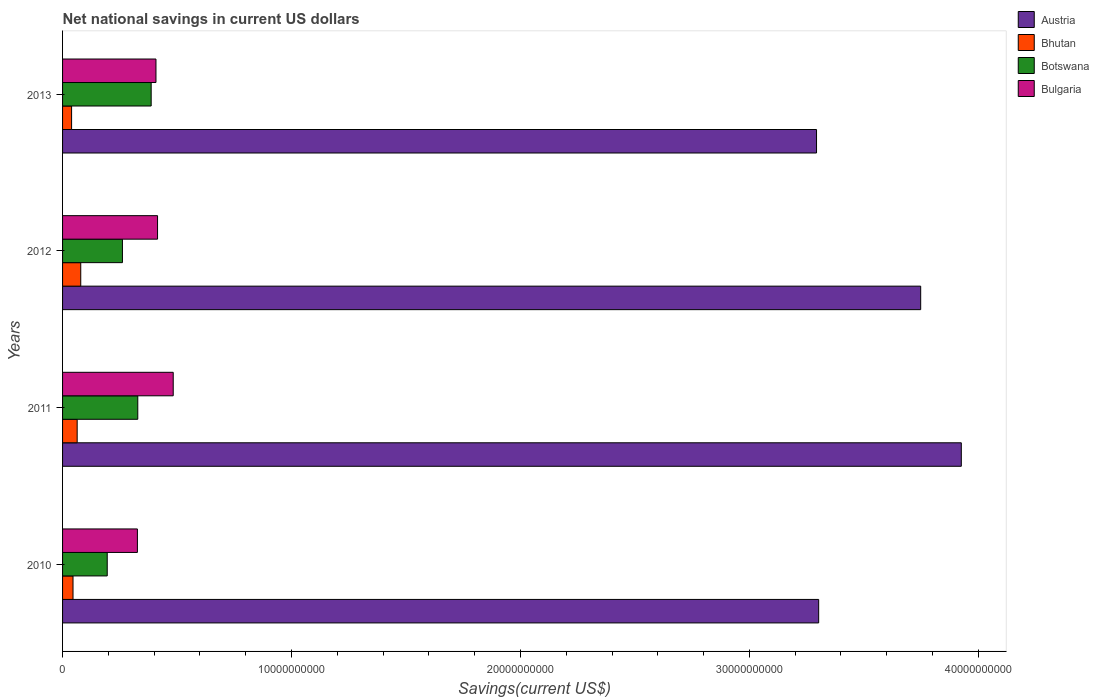How many groups of bars are there?
Make the answer very short. 4. Are the number of bars per tick equal to the number of legend labels?
Ensure brevity in your answer.  Yes. How many bars are there on the 2nd tick from the bottom?
Provide a short and direct response. 4. What is the net national savings in Botswana in 2010?
Give a very brief answer. 1.95e+09. Across all years, what is the maximum net national savings in Austria?
Ensure brevity in your answer.  3.93e+1. Across all years, what is the minimum net national savings in Botswana?
Your response must be concise. 1.95e+09. What is the total net national savings in Bhutan in the graph?
Offer a terse response. 2.28e+09. What is the difference between the net national savings in Austria in 2010 and that in 2013?
Give a very brief answer. 9.34e+07. What is the difference between the net national savings in Botswana in 2011 and the net national savings in Austria in 2012?
Make the answer very short. -3.42e+1. What is the average net national savings in Bhutan per year?
Provide a short and direct response. 5.71e+08. In the year 2011, what is the difference between the net national savings in Austria and net national savings in Bulgaria?
Keep it short and to the point. 3.44e+1. What is the ratio of the net national savings in Bulgaria in 2012 to that in 2013?
Provide a short and direct response. 1.02. Is the difference between the net national savings in Austria in 2011 and 2013 greater than the difference between the net national savings in Bulgaria in 2011 and 2013?
Keep it short and to the point. Yes. What is the difference between the highest and the second highest net national savings in Austria?
Offer a very short reply. 1.77e+09. What is the difference between the highest and the lowest net national savings in Botswana?
Provide a succinct answer. 1.92e+09. Is the sum of the net national savings in Bulgaria in 2011 and 2012 greater than the maximum net national savings in Botswana across all years?
Provide a succinct answer. Yes. What does the 4th bar from the top in 2010 represents?
Provide a succinct answer. Austria. Is it the case that in every year, the sum of the net national savings in Bhutan and net national savings in Botswana is greater than the net national savings in Bulgaria?
Offer a terse response. No. How many bars are there?
Ensure brevity in your answer.  16. Where does the legend appear in the graph?
Give a very brief answer. Top right. How many legend labels are there?
Your answer should be compact. 4. What is the title of the graph?
Offer a terse response. Net national savings in current US dollars. Does "Macedonia" appear as one of the legend labels in the graph?
Offer a terse response. No. What is the label or title of the X-axis?
Provide a succinct answer. Savings(current US$). What is the Savings(current US$) in Austria in 2010?
Make the answer very short. 3.30e+1. What is the Savings(current US$) of Bhutan in 2010?
Give a very brief answer. 4.57e+08. What is the Savings(current US$) in Botswana in 2010?
Ensure brevity in your answer.  1.95e+09. What is the Savings(current US$) of Bulgaria in 2010?
Offer a terse response. 3.27e+09. What is the Savings(current US$) of Austria in 2011?
Your response must be concise. 3.93e+1. What is the Savings(current US$) in Bhutan in 2011?
Give a very brief answer. 6.38e+08. What is the Savings(current US$) of Botswana in 2011?
Offer a very short reply. 3.29e+09. What is the Savings(current US$) in Bulgaria in 2011?
Make the answer very short. 4.83e+09. What is the Savings(current US$) in Austria in 2012?
Keep it short and to the point. 3.75e+1. What is the Savings(current US$) of Bhutan in 2012?
Your response must be concise. 7.94e+08. What is the Savings(current US$) in Botswana in 2012?
Your answer should be very brief. 2.62e+09. What is the Savings(current US$) of Bulgaria in 2012?
Offer a terse response. 4.15e+09. What is the Savings(current US$) in Austria in 2013?
Keep it short and to the point. 3.29e+1. What is the Savings(current US$) of Bhutan in 2013?
Give a very brief answer. 3.94e+08. What is the Savings(current US$) of Botswana in 2013?
Keep it short and to the point. 3.87e+09. What is the Savings(current US$) of Bulgaria in 2013?
Provide a short and direct response. 4.08e+09. Across all years, what is the maximum Savings(current US$) of Austria?
Your answer should be very brief. 3.93e+1. Across all years, what is the maximum Savings(current US$) of Bhutan?
Offer a very short reply. 7.94e+08. Across all years, what is the maximum Savings(current US$) of Botswana?
Keep it short and to the point. 3.87e+09. Across all years, what is the maximum Savings(current US$) of Bulgaria?
Offer a very short reply. 4.83e+09. Across all years, what is the minimum Savings(current US$) of Austria?
Provide a succinct answer. 3.29e+1. Across all years, what is the minimum Savings(current US$) in Bhutan?
Your response must be concise. 3.94e+08. Across all years, what is the minimum Savings(current US$) in Botswana?
Provide a succinct answer. 1.95e+09. Across all years, what is the minimum Savings(current US$) in Bulgaria?
Ensure brevity in your answer.  3.27e+09. What is the total Savings(current US$) in Austria in the graph?
Give a very brief answer. 1.43e+11. What is the total Savings(current US$) of Bhutan in the graph?
Your response must be concise. 2.28e+09. What is the total Savings(current US$) in Botswana in the graph?
Offer a very short reply. 1.17e+1. What is the total Savings(current US$) of Bulgaria in the graph?
Ensure brevity in your answer.  1.63e+1. What is the difference between the Savings(current US$) of Austria in 2010 and that in 2011?
Your answer should be compact. -6.23e+09. What is the difference between the Savings(current US$) in Bhutan in 2010 and that in 2011?
Give a very brief answer. -1.82e+08. What is the difference between the Savings(current US$) of Botswana in 2010 and that in 2011?
Give a very brief answer. -1.33e+09. What is the difference between the Savings(current US$) of Bulgaria in 2010 and that in 2011?
Offer a very short reply. -1.56e+09. What is the difference between the Savings(current US$) in Austria in 2010 and that in 2012?
Keep it short and to the point. -4.46e+09. What is the difference between the Savings(current US$) of Bhutan in 2010 and that in 2012?
Your response must be concise. -3.38e+08. What is the difference between the Savings(current US$) of Botswana in 2010 and that in 2012?
Offer a terse response. -6.65e+08. What is the difference between the Savings(current US$) in Bulgaria in 2010 and that in 2012?
Ensure brevity in your answer.  -8.79e+08. What is the difference between the Savings(current US$) in Austria in 2010 and that in 2013?
Offer a very short reply. 9.34e+07. What is the difference between the Savings(current US$) of Bhutan in 2010 and that in 2013?
Give a very brief answer. 6.21e+07. What is the difference between the Savings(current US$) in Botswana in 2010 and that in 2013?
Offer a terse response. -1.92e+09. What is the difference between the Savings(current US$) in Bulgaria in 2010 and that in 2013?
Provide a succinct answer. -8.11e+08. What is the difference between the Savings(current US$) of Austria in 2011 and that in 2012?
Your response must be concise. 1.77e+09. What is the difference between the Savings(current US$) in Bhutan in 2011 and that in 2012?
Your response must be concise. -1.56e+08. What is the difference between the Savings(current US$) of Botswana in 2011 and that in 2012?
Provide a short and direct response. 6.70e+08. What is the difference between the Savings(current US$) in Bulgaria in 2011 and that in 2012?
Provide a succinct answer. 6.85e+08. What is the difference between the Savings(current US$) in Austria in 2011 and that in 2013?
Ensure brevity in your answer.  6.32e+09. What is the difference between the Savings(current US$) in Bhutan in 2011 and that in 2013?
Your response must be concise. 2.44e+08. What is the difference between the Savings(current US$) of Botswana in 2011 and that in 2013?
Your answer should be very brief. -5.85e+08. What is the difference between the Savings(current US$) in Bulgaria in 2011 and that in 2013?
Your response must be concise. 7.54e+08. What is the difference between the Savings(current US$) in Austria in 2012 and that in 2013?
Provide a short and direct response. 4.55e+09. What is the difference between the Savings(current US$) in Bhutan in 2012 and that in 2013?
Make the answer very short. 4.00e+08. What is the difference between the Savings(current US$) in Botswana in 2012 and that in 2013?
Ensure brevity in your answer.  -1.26e+09. What is the difference between the Savings(current US$) in Bulgaria in 2012 and that in 2013?
Your response must be concise. 6.89e+07. What is the difference between the Savings(current US$) in Austria in 2010 and the Savings(current US$) in Bhutan in 2011?
Your answer should be very brief. 3.24e+1. What is the difference between the Savings(current US$) of Austria in 2010 and the Savings(current US$) of Botswana in 2011?
Ensure brevity in your answer.  2.97e+1. What is the difference between the Savings(current US$) in Austria in 2010 and the Savings(current US$) in Bulgaria in 2011?
Keep it short and to the point. 2.82e+1. What is the difference between the Savings(current US$) of Bhutan in 2010 and the Savings(current US$) of Botswana in 2011?
Give a very brief answer. -2.83e+09. What is the difference between the Savings(current US$) of Bhutan in 2010 and the Savings(current US$) of Bulgaria in 2011?
Your response must be concise. -4.38e+09. What is the difference between the Savings(current US$) of Botswana in 2010 and the Savings(current US$) of Bulgaria in 2011?
Your answer should be very brief. -2.88e+09. What is the difference between the Savings(current US$) of Austria in 2010 and the Savings(current US$) of Bhutan in 2012?
Offer a terse response. 3.22e+1. What is the difference between the Savings(current US$) in Austria in 2010 and the Savings(current US$) in Botswana in 2012?
Offer a terse response. 3.04e+1. What is the difference between the Savings(current US$) in Austria in 2010 and the Savings(current US$) in Bulgaria in 2012?
Your answer should be compact. 2.89e+1. What is the difference between the Savings(current US$) in Bhutan in 2010 and the Savings(current US$) in Botswana in 2012?
Make the answer very short. -2.16e+09. What is the difference between the Savings(current US$) of Bhutan in 2010 and the Savings(current US$) of Bulgaria in 2012?
Offer a very short reply. -3.69e+09. What is the difference between the Savings(current US$) of Botswana in 2010 and the Savings(current US$) of Bulgaria in 2012?
Offer a terse response. -2.20e+09. What is the difference between the Savings(current US$) of Austria in 2010 and the Savings(current US$) of Bhutan in 2013?
Provide a succinct answer. 3.26e+1. What is the difference between the Savings(current US$) of Austria in 2010 and the Savings(current US$) of Botswana in 2013?
Keep it short and to the point. 2.92e+1. What is the difference between the Savings(current US$) of Austria in 2010 and the Savings(current US$) of Bulgaria in 2013?
Offer a very short reply. 2.89e+1. What is the difference between the Savings(current US$) of Bhutan in 2010 and the Savings(current US$) of Botswana in 2013?
Your response must be concise. -3.41e+09. What is the difference between the Savings(current US$) in Bhutan in 2010 and the Savings(current US$) in Bulgaria in 2013?
Your answer should be very brief. -3.62e+09. What is the difference between the Savings(current US$) of Botswana in 2010 and the Savings(current US$) of Bulgaria in 2013?
Keep it short and to the point. -2.13e+09. What is the difference between the Savings(current US$) in Austria in 2011 and the Savings(current US$) in Bhutan in 2012?
Make the answer very short. 3.85e+1. What is the difference between the Savings(current US$) of Austria in 2011 and the Savings(current US$) of Botswana in 2012?
Give a very brief answer. 3.66e+1. What is the difference between the Savings(current US$) of Austria in 2011 and the Savings(current US$) of Bulgaria in 2012?
Your answer should be compact. 3.51e+1. What is the difference between the Savings(current US$) in Bhutan in 2011 and the Savings(current US$) in Botswana in 2012?
Your answer should be compact. -1.98e+09. What is the difference between the Savings(current US$) in Bhutan in 2011 and the Savings(current US$) in Bulgaria in 2012?
Your answer should be compact. -3.51e+09. What is the difference between the Savings(current US$) in Botswana in 2011 and the Savings(current US$) in Bulgaria in 2012?
Your response must be concise. -8.64e+08. What is the difference between the Savings(current US$) in Austria in 2011 and the Savings(current US$) in Bhutan in 2013?
Provide a short and direct response. 3.89e+1. What is the difference between the Savings(current US$) of Austria in 2011 and the Savings(current US$) of Botswana in 2013?
Your answer should be compact. 3.54e+1. What is the difference between the Savings(current US$) in Austria in 2011 and the Savings(current US$) in Bulgaria in 2013?
Keep it short and to the point. 3.52e+1. What is the difference between the Savings(current US$) of Bhutan in 2011 and the Savings(current US$) of Botswana in 2013?
Your answer should be very brief. -3.23e+09. What is the difference between the Savings(current US$) of Bhutan in 2011 and the Savings(current US$) of Bulgaria in 2013?
Give a very brief answer. -3.44e+09. What is the difference between the Savings(current US$) of Botswana in 2011 and the Savings(current US$) of Bulgaria in 2013?
Make the answer very short. -7.95e+08. What is the difference between the Savings(current US$) of Austria in 2012 and the Savings(current US$) of Bhutan in 2013?
Give a very brief answer. 3.71e+1. What is the difference between the Savings(current US$) in Austria in 2012 and the Savings(current US$) in Botswana in 2013?
Provide a succinct answer. 3.36e+1. What is the difference between the Savings(current US$) of Austria in 2012 and the Savings(current US$) of Bulgaria in 2013?
Your answer should be compact. 3.34e+1. What is the difference between the Savings(current US$) of Bhutan in 2012 and the Savings(current US$) of Botswana in 2013?
Provide a succinct answer. -3.08e+09. What is the difference between the Savings(current US$) of Bhutan in 2012 and the Savings(current US$) of Bulgaria in 2013?
Your answer should be compact. -3.29e+09. What is the difference between the Savings(current US$) of Botswana in 2012 and the Savings(current US$) of Bulgaria in 2013?
Offer a terse response. -1.46e+09. What is the average Savings(current US$) of Austria per year?
Make the answer very short. 3.57e+1. What is the average Savings(current US$) of Bhutan per year?
Your answer should be compact. 5.71e+08. What is the average Savings(current US$) in Botswana per year?
Make the answer very short. 2.93e+09. What is the average Savings(current US$) in Bulgaria per year?
Provide a short and direct response. 4.08e+09. In the year 2010, what is the difference between the Savings(current US$) in Austria and Savings(current US$) in Bhutan?
Your response must be concise. 3.26e+1. In the year 2010, what is the difference between the Savings(current US$) of Austria and Savings(current US$) of Botswana?
Keep it short and to the point. 3.11e+1. In the year 2010, what is the difference between the Savings(current US$) in Austria and Savings(current US$) in Bulgaria?
Give a very brief answer. 2.98e+1. In the year 2010, what is the difference between the Savings(current US$) in Bhutan and Savings(current US$) in Botswana?
Ensure brevity in your answer.  -1.49e+09. In the year 2010, what is the difference between the Savings(current US$) in Bhutan and Savings(current US$) in Bulgaria?
Ensure brevity in your answer.  -2.81e+09. In the year 2010, what is the difference between the Savings(current US$) of Botswana and Savings(current US$) of Bulgaria?
Make the answer very short. -1.32e+09. In the year 2011, what is the difference between the Savings(current US$) in Austria and Savings(current US$) in Bhutan?
Your answer should be very brief. 3.86e+1. In the year 2011, what is the difference between the Savings(current US$) of Austria and Savings(current US$) of Botswana?
Offer a terse response. 3.60e+1. In the year 2011, what is the difference between the Savings(current US$) in Austria and Savings(current US$) in Bulgaria?
Keep it short and to the point. 3.44e+1. In the year 2011, what is the difference between the Savings(current US$) in Bhutan and Savings(current US$) in Botswana?
Give a very brief answer. -2.65e+09. In the year 2011, what is the difference between the Savings(current US$) in Bhutan and Savings(current US$) in Bulgaria?
Keep it short and to the point. -4.20e+09. In the year 2011, what is the difference between the Savings(current US$) in Botswana and Savings(current US$) in Bulgaria?
Provide a succinct answer. -1.55e+09. In the year 2012, what is the difference between the Savings(current US$) of Austria and Savings(current US$) of Bhutan?
Offer a terse response. 3.67e+1. In the year 2012, what is the difference between the Savings(current US$) in Austria and Savings(current US$) in Botswana?
Keep it short and to the point. 3.49e+1. In the year 2012, what is the difference between the Savings(current US$) of Austria and Savings(current US$) of Bulgaria?
Your answer should be very brief. 3.33e+1. In the year 2012, what is the difference between the Savings(current US$) in Bhutan and Savings(current US$) in Botswana?
Give a very brief answer. -1.82e+09. In the year 2012, what is the difference between the Savings(current US$) of Bhutan and Savings(current US$) of Bulgaria?
Offer a very short reply. -3.35e+09. In the year 2012, what is the difference between the Savings(current US$) in Botswana and Savings(current US$) in Bulgaria?
Make the answer very short. -1.53e+09. In the year 2013, what is the difference between the Savings(current US$) in Austria and Savings(current US$) in Bhutan?
Offer a terse response. 3.25e+1. In the year 2013, what is the difference between the Savings(current US$) of Austria and Savings(current US$) of Botswana?
Give a very brief answer. 2.91e+1. In the year 2013, what is the difference between the Savings(current US$) of Austria and Savings(current US$) of Bulgaria?
Offer a very short reply. 2.89e+1. In the year 2013, what is the difference between the Savings(current US$) of Bhutan and Savings(current US$) of Botswana?
Ensure brevity in your answer.  -3.48e+09. In the year 2013, what is the difference between the Savings(current US$) in Bhutan and Savings(current US$) in Bulgaria?
Your answer should be very brief. -3.69e+09. In the year 2013, what is the difference between the Savings(current US$) in Botswana and Savings(current US$) in Bulgaria?
Give a very brief answer. -2.10e+08. What is the ratio of the Savings(current US$) of Austria in 2010 to that in 2011?
Ensure brevity in your answer.  0.84. What is the ratio of the Savings(current US$) of Bhutan in 2010 to that in 2011?
Provide a succinct answer. 0.72. What is the ratio of the Savings(current US$) of Botswana in 2010 to that in 2011?
Your answer should be very brief. 0.59. What is the ratio of the Savings(current US$) of Bulgaria in 2010 to that in 2011?
Provide a succinct answer. 0.68. What is the ratio of the Savings(current US$) of Austria in 2010 to that in 2012?
Offer a terse response. 0.88. What is the ratio of the Savings(current US$) in Bhutan in 2010 to that in 2012?
Your answer should be compact. 0.57. What is the ratio of the Savings(current US$) in Botswana in 2010 to that in 2012?
Ensure brevity in your answer.  0.75. What is the ratio of the Savings(current US$) of Bulgaria in 2010 to that in 2012?
Give a very brief answer. 0.79. What is the ratio of the Savings(current US$) in Austria in 2010 to that in 2013?
Your answer should be very brief. 1. What is the ratio of the Savings(current US$) of Bhutan in 2010 to that in 2013?
Ensure brevity in your answer.  1.16. What is the ratio of the Savings(current US$) of Botswana in 2010 to that in 2013?
Keep it short and to the point. 0.5. What is the ratio of the Savings(current US$) of Bulgaria in 2010 to that in 2013?
Provide a succinct answer. 0.8. What is the ratio of the Savings(current US$) of Austria in 2011 to that in 2012?
Provide a succinct answer. 1.05. What is the ratio of the Savings(current US$) in Bhutan in 2011 to that in 2012?
Provide a short and direct response. 0.8. What is the ratio of the Savings(current US$) in Botswana in 2011 to that in 2012?
Offer a terse response. 1.26. What is the ratio of the Savings(current US$) of Bulgaria in 2011 to that in 2012?
Offer a very short reply. 1.17. What is the ratio of the Savings(current US$) in Austria in 2011 to that in 2013?
Your response must be concise. 1.19. What is the ratio of the Savings(current US$) of Bhutan in 2011 to that in 2013?
Make the answer very short. 1.62. What is the ratio of the Savings(current US$) in Botswana in 2011 to that in 2013?
Ensure brevity in your answer.  0.85. What is the ratio of the Savings(current US$) of Bulgaria in 2011 to that in 2013?
Your answer should be very brief. 1.18. What is the ratio of the Savings(current US$) of Austria in 2012 to that in 2013?
Offer a terse response. 1.14. What is the ratio of the Savings(current US$) in Bhutan in 2012 to that in 2013?
Offer a terse response. 2.01. What is the ratio of the Savings(current US$) in Botswana in 2012 to that in 2013?
Give a very brief answer. 0.68. What is the ratio of the Savings(current US$) of Bulgaria in 2012 to that in 2013?
Your answer should be very brief. 1.02. What is the difference between the highest and the second highest Savings(current US$) in Austria?
Keep it short and to the point. 1.77e+09. What is the difference between the highest and the second highest Savings(current US$) of Bhutan?
Your response must be concise. 1.56e+08. What is the difference between the highest and the second highest Savings(current US$) in Botswana?
Your answer should be compact. 5.85e+08. What is the difference between the highest and the second highest Savings(current US$) in Bulgaria?
Your answer should be very brief. 6.85e+08. What is the difference between the highest and the lowest Savings(current US$) of Austria?
Your response must be concise. 6.32e+09. What is the difference between the highest and the lowest Savings(current US$) of Bhutan?
Your response must be concise. 4.00e+08. What is the difference between the highest and the lowest Savings(current US$) of Botswana?
Your answer should be very brief. 1.92e+09. What is the difference between the highest and the lowest Savings(current US$) of Bulgaria?
Give a very brief answer. 1.56e+09. 